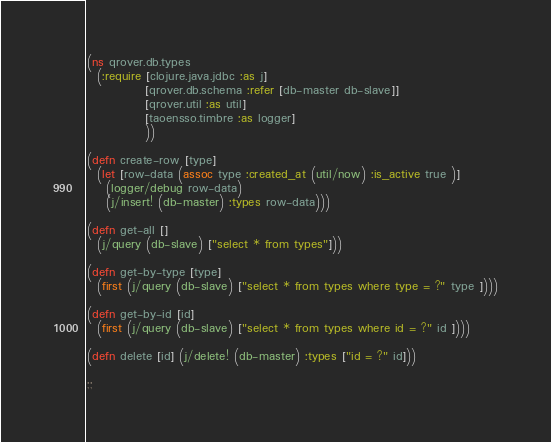<code> <loc_0><loc_0><loc_500><loc_500><_Clojure_>(ns qrover.db.types
  (:require [clojure.java.jdbc :as j]
            [qrover.db.schema :refer [db-master db-slave]]
            [qrover.util :as util]
            [taoensso.timbre :as logger]
            ))

(defn create-row [type]
  (let [row-data (assoc type :created_at (util/now) :is_active true )]
    (logger/debug row-data)
    (j/insert! (db-master) :types row-data)))

(defn get-all []
  (j/query (db-slave) ["select * from types"]))

(defn get-by-type [type]
  (first (j/query (db-slave) ["select * from types where type = ?" type ])))

(defn get-by-id [id]
  (first (j/query (db-slave) ["select * from types where id = ?" id ])))

(defn delete [id] (j/delete! (db-master) :types ["id = ?" id]))

;;
</code> 